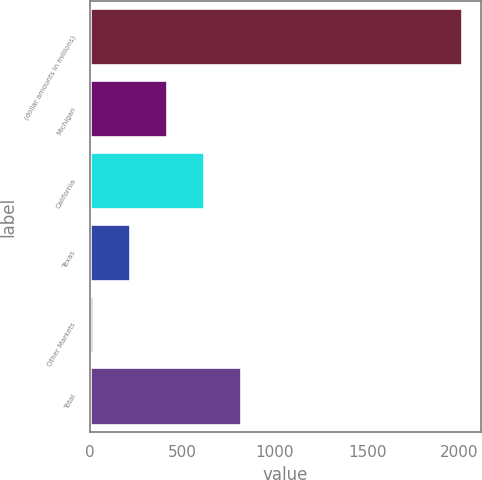<chart> <loc_0><loc_0><loc_500><loc_500><bar_chart><fcel>(dollar amounts in millions)<fcel>Michigan<fcel>California<fcel>Texas<fcel>Other Markets<fcel>Total<nl><fcel>2015<fcel>415<fcel>615<fcel>215<fcel>15<fcel>815<nl></chart> 